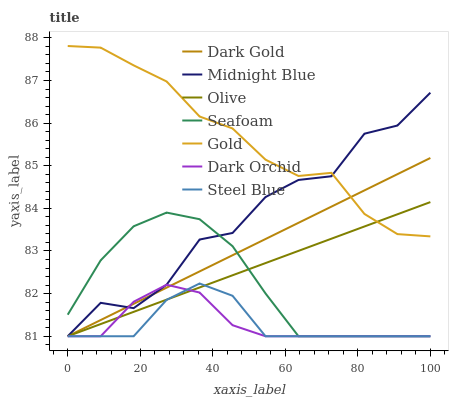Does Steel Blue have the minimum area under the curve?
Answer yes or no. Yes. Does Gold have the maximum area under the curve?
Answer yes or no. Yes. Does Dark Gold have the minimum area under the curve?
Answer yes or no. No. Does Dark Gold have the maximum area under the curve?
Answer yes or no. No. Is Olive the smoothest?
Answer yes or no. Yes. Is Midnight Blue the roughest?
Answer yes or no. Yes. Is Gold the smoothest?
Answer yes or no. No. Is Gold the roughest?
Answer yes or no. No. Does Gold have the lowest value?
Answer yes or no. No. Does Dark Gold have the highest value?
Answer yes or no. No. Is Dark Orchid less than Gold?
Answer yes or no. Yes. Is Gold greater than Dark Orchid?
Answer yes or no. Yes. Does Dark Orchid intersect Gold?
Answer yes or no. No. 